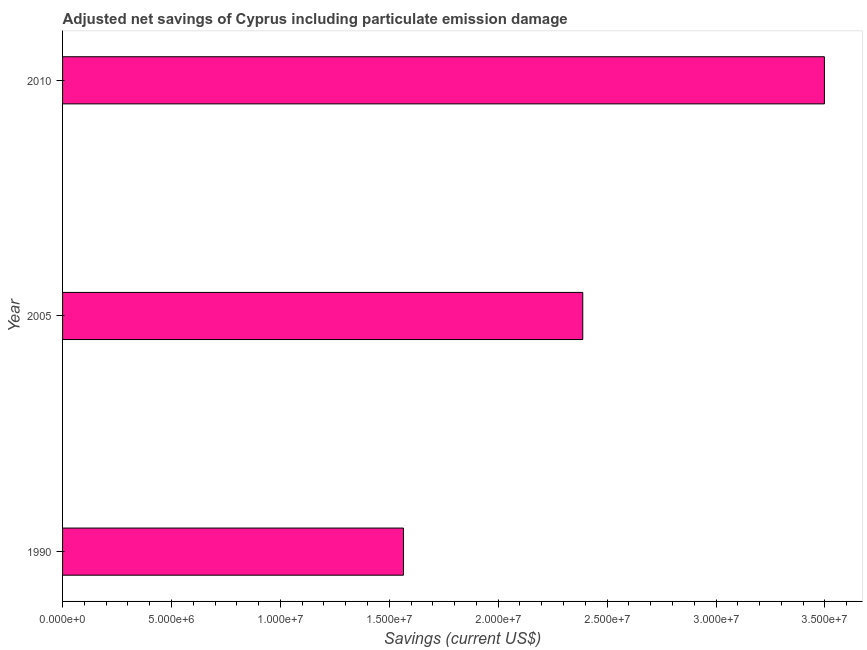Does the graph contain any zero values?
Give a very brief answer. No. What is the title of the graph?
Your answer should be very brief. Adjusted net savings of Cyprus including particulate emission damage. What is the label or title of the X-axis?
Offer a terse response. Savings (current US$). What is the label or title of the Y-axis?
Your response must be concise. Year. What is the adjusted net savings in 1990?
Ensure brevity in your answer.  1.57e+07. Across all years, what is the maximum adjusted net savings?
Make the answer very short. 3.50e+07. Across all years, what is the minimum adjusted net savings?
Keep it short and to the point. 1.57e+07. In which year was the adjusted net savings minimum?
Your response must be concise. 1990. What is the sum of the adjusted net savings?
Ensure brevity in your answer.  7.45e+07. What is the difference between the adjusted net savings in 1990 and 2005?
Give a very brief answer. -8.23e+06. What is the average adjusted net savings per year?
Your response must be concise. 2.48e+07. What is the median adjusted net savings?
Your response must be concise. 2.39e+07. In how many years, is the adjusted net savings greater than 28000000 US$?
Your answer should be very brief. 1. Do a majority of the years between 2010 and 2005 (inclusive) have adjusted net savings greater than 10000000 US$?
Give a very brief answer. No. What is the ratio of the adjusted net savings in 1990 to that in 2010?
Offer a very short reply. 0.45. Is the adjusted net savings in 1990 less than that in 2005?
Your answer should be very brief. Yes. What is the difference between the highest and the second highest adjusted net savings?
Give a very brief answer. 1.11e+07. What is the difference between the highest and the lowest adjusted net savings?
Ensure brevity in your answer.  1.93e+07. How many bars are there?
Your answer should be very brief. 3. Are all the bars in the graph horizontal?
Provide a short and direct response. Yes. Are the values on the major ticks of X-axis written in scientific E-notation?
Ensure brevity in your answer.  Yes. What is the Savings (current US$) of 1990?
Make the answer very short. 1.57e+07. What is the Savings (current US$) in 2005?
Your answer should be very brief. 2.39e+07. What is the Savings (current US$) of 2010?
Your answer should be very brief. 3.50e+07. What is the difference between the Savings (current US$) in 1990 and 2005?
Your answer should be compact. -8.23e+06. What is the difference between the Savings (current US$) in 1990 and 2010?
Offer a terse response. -1.93e+07. What is the difference between the Savings (current US$) in 2005 and 2010?
Keep it short and to the point. -1.11e+07. What is the ratio of the Savings (current US$) in 1990 to that in 2005?
Keep it short and to the point. 0.66. What is the ratio of the Savings (current US$) in 1990 to that in 2010?
Make the answer very short. 0.45. What is the ratio of the Savings (current US$) in 2005 to that in 2010?
Your response must be concise. 0.68. 